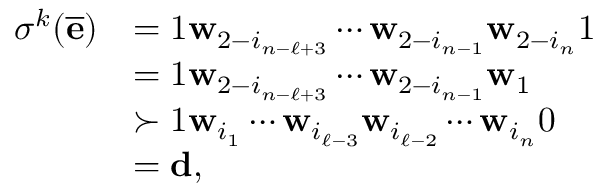Convert formula to latex. <formula><loc_0><loc_0><loc_500><loc_500>\begin{array} { r l } { \sigma ^ { k } ( \overline { \mathbf e } ) } & { = 1 \mathbf w _ { 2 - i _ { n - \ell + 3 } } \cdots \mathbf w _ { 2 - i _ { n - 1 } } \mathbf w _ { 2 - i _ { n } } 1 } \\ & { = 1 \mathbf w _ { 2 - i _ { n - \ell + 3 } } \cdots \mathbf w _ { 2 - i _ { n - 1 } } \mathbf w _ { 1 } } \\ & { \succ 1 \mathbf w _ { i _ { 1 } } \cdots \mathbf w _ { i _ { \ell - 3 } } \mathbf w _ { i _ { \ell - 2 } } \cdots \mathbf w _ { i _ { n } } 0 } \\ & { = \mathbf d , } \end{array}</formula> 